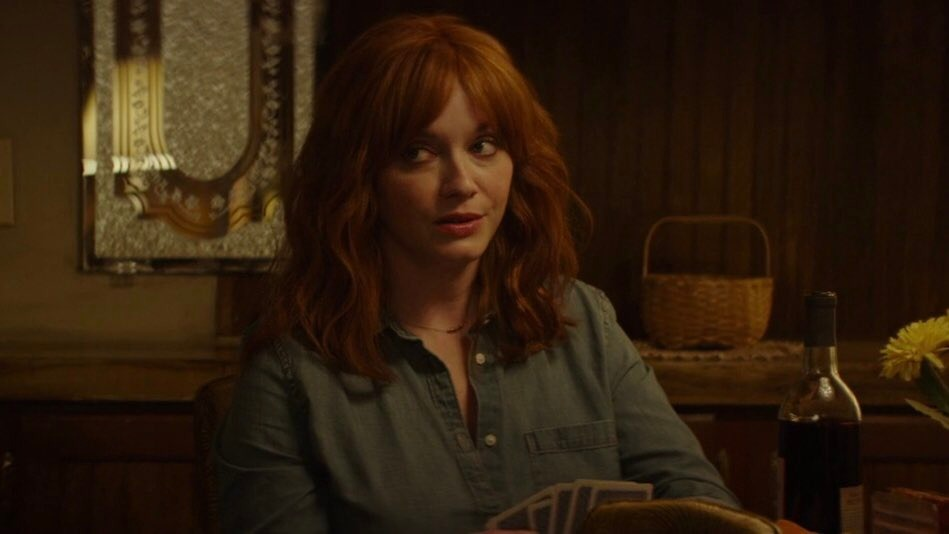What do you think is going on in this snapshot? In this image, Christina Hendricks, recognizable for her role in television, is seated at a wooden table. The setting is warmly lit, giving an intimate ambiance. A bottle of wine and a vase filled with yellow flowers adorn the table, adding touches of color and character. Christina, dressed casually in a blue denim shirt, draws attention with her vivid red hair. Her expression appears somewhat puzzled or inquisitive, as she looks off to the side, perhaps contemplating a situation or reacting to an unseen person or event. The elements together create a scene filled with potential narratives — perhaps hinting at a contemplative moment in an unfolding story. 